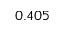Convert formula to latex. <formula><loc_0><loc_0><loc_500><loc_500>0 . 4 0 5</formula> 